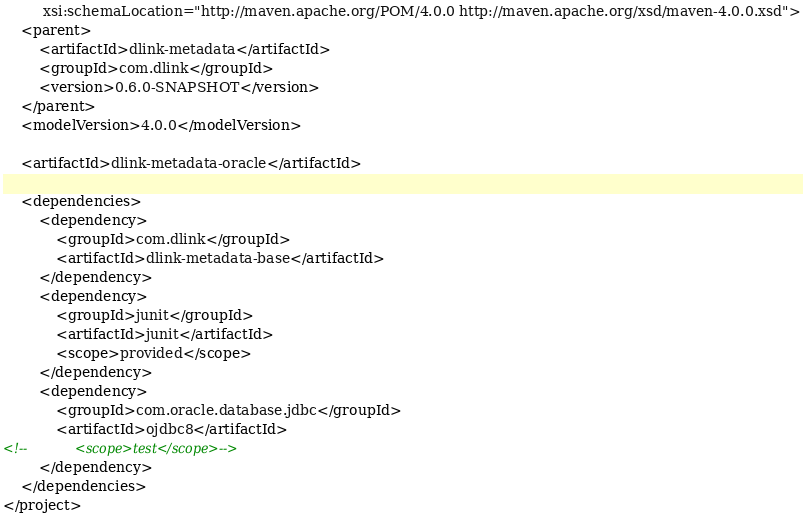<code> <loc_0><loc_0><loc_500><loc_500><_XML_>         xsi:schemaLocation="http://maven.apache.org/POM/4.0.0 http://maven.apache.org/xsd/maven-4.0.0.xsd">
    <parent>
        <artifactId>dlink-metadata</artifactId>
        <groupId>com.dlink</groupId>
        <version>0.6.0-SNAPSHOT</version>
    </parent>
    <modelVersion>4.0.0</modelVersion>

    <artifactId>dlink-metadata-oracle</artifactId>

    <dependencies>
        <dependency>
            <groupId>com.dlink</groupId>
            <artifactId>dlink-metadata-base</artifactId>
        </dependency>
        <dependency>
            <groupId>junit</groupId>
            <artifactId>junit</artifactId>
            <scope>provided</scope>
        </dependency>
        <dependency>
            <groupId>com.oracle.database.jdbc</groupId>
            <artifactId>ojdbc8</artifactId>
<!--            <scope>test</scope>-->
        </dependency>
    </dependencies>
</project></code> 